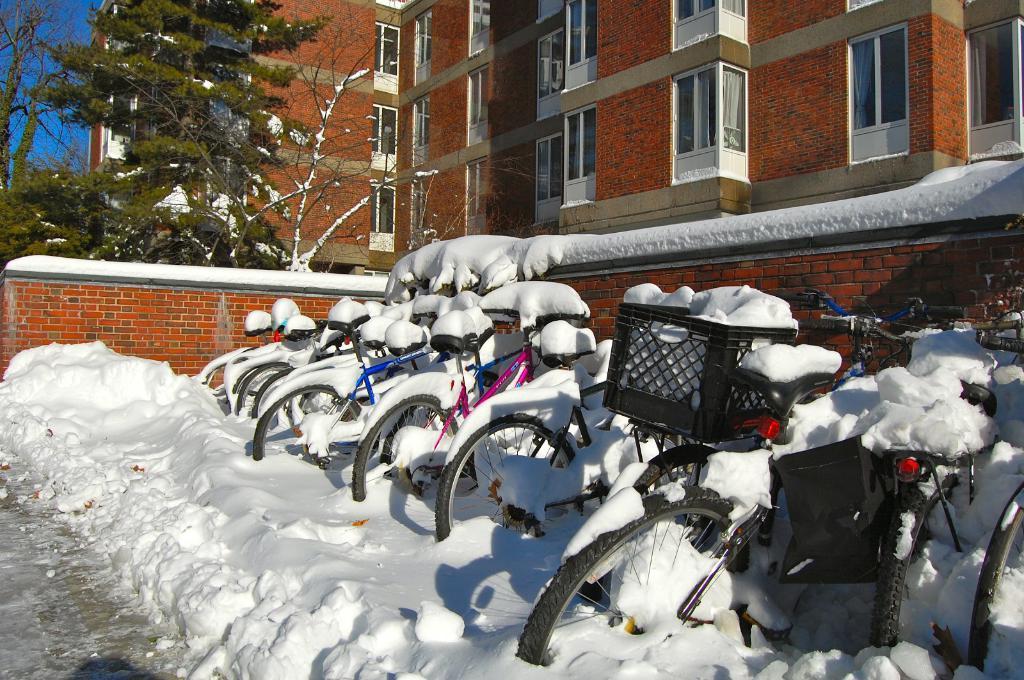Please provide a concise description of this image. In this image there are bicycles covered with snow, there is a wall and building, trees those all are covered with snow. 